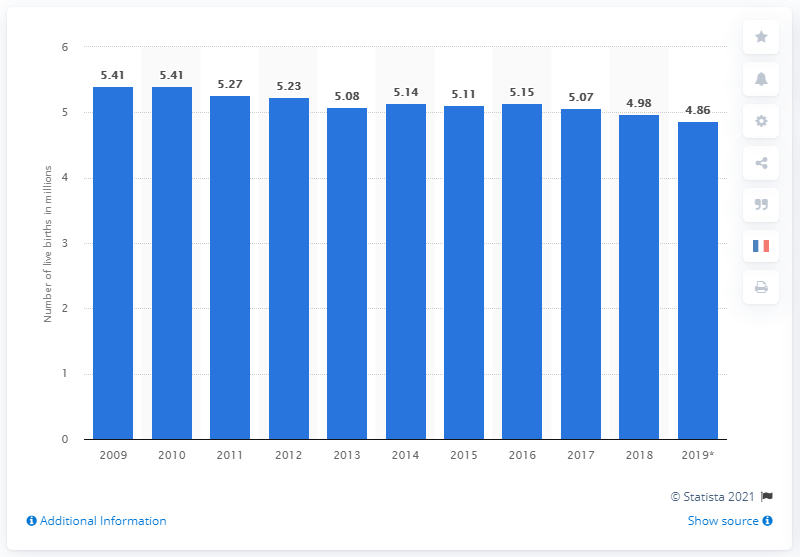Give some essential details in this illustration. In 2017, the European Union reported that a total of 5.07 million babies were born. 